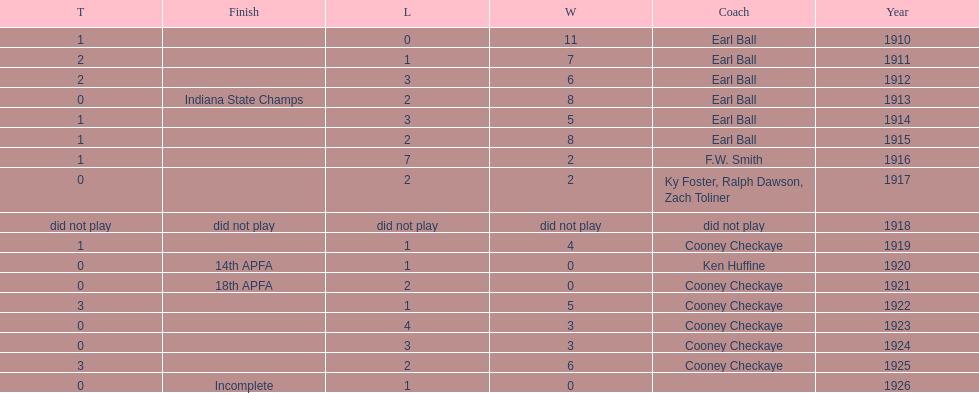In what year did the muncie flyers have an undefeated record? 1910. 